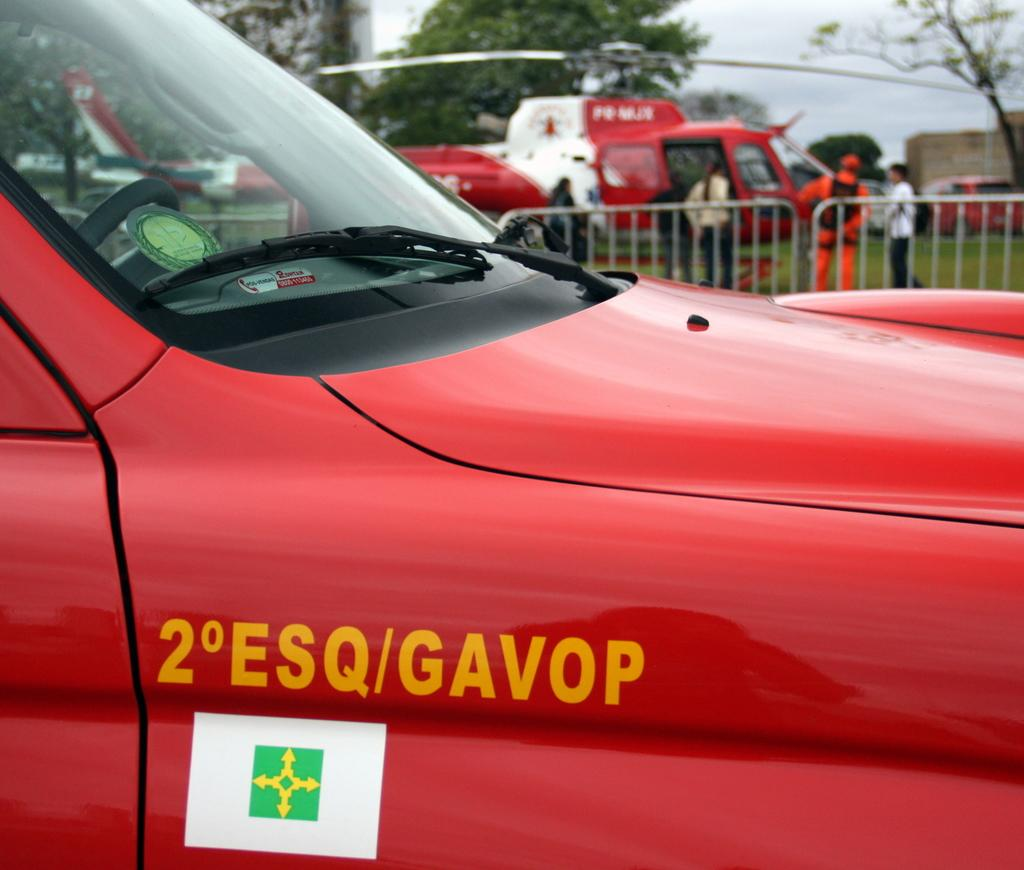<image>
Summarize the visual content of the image. the number 2 that is on the side of a car 